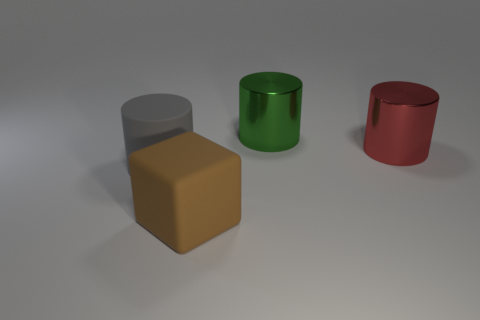Add 2 metallic objects. How many objects exist? 6 Subtract all cubes. How many objects are left? 3 Subtract 0 gray balls. How many objects are left? 4 Subtract all cyan matte balls. Subtract all big brown rubber cubes. How many objects are left? 3 Add 3 big green metallic cylinders. How many big green metallic cylinders are left? 4 Add 3 red metal things. How many red metal things exist? 4 